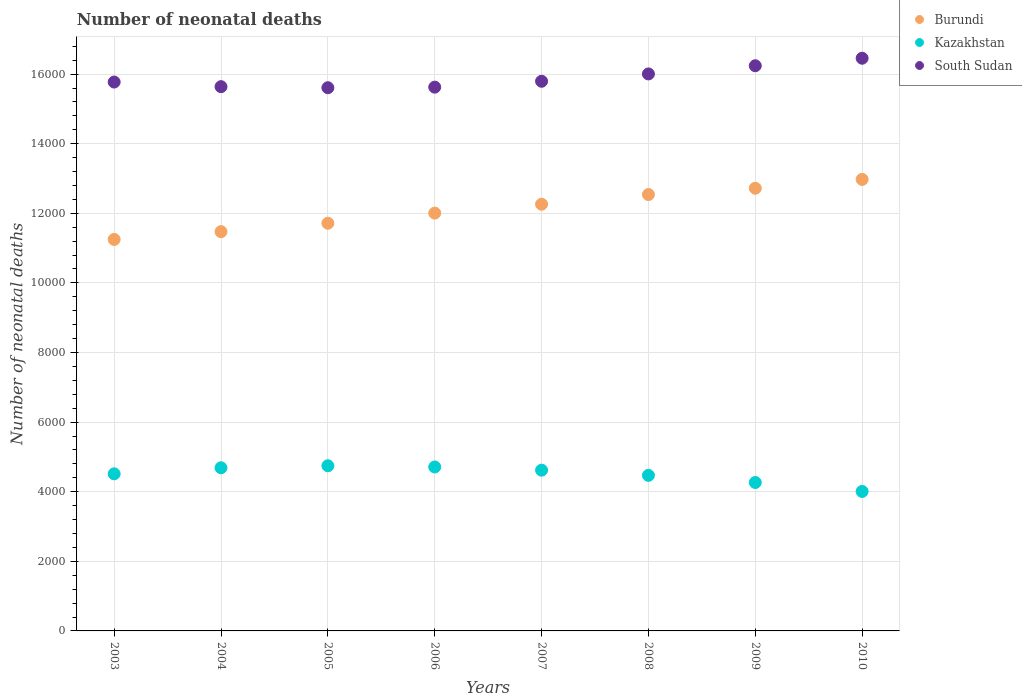How many different coloured dotlines are there?
Offer a terse response. 3. Is the number of dotlines equal to the number of legend labels?
Your answer should be very brief. Yes. What is the number of neonatal deaths in in Burundi in 2004?
Offer a terse response. 1.15e+04. Across all years, what is the maximum number of neonatal deaths in in Burundi?
Give a very brief answer. 1.30e+04. Across all years, what is the minimum number of neonatal deaths in in South Sudan?
Provide a short and direct response. 1.56e+04. What is the total number of neonatal deaths in in South Sudan in the graph?
Ensure brevity in your answer.  1.27e+05. What is the difference between the number of neonatal deaths in in Kazakhstan in 2008 and that in 2009?
Ensure brevity in your answer.  205. What is the difference between the number of neonatal deaths in in South Sudan in 2003 and the number of neonatal deaths in in Kazakhstan in 2009?
Your response must be concise. 1.15e+04. What is the average number of neonatal deaths in in South Sudan per year?
Offer a very short reply. 1.59e+04. In the year 2005, what is the difference between the number of neonatal deaths in in Burundi and number of neonatal deaths in in Kazakhstan?
Offer a very short reply. 6969. What is the ratio of the number of neonatal deaths in in Burundi in 2005 to that in 2009?
Ensure brevity in your answer.  0.92. Is the difference between the number of neonatal deaths in in Burundi in 2004 and 2005 greater than the difference between the number of neonatal deaths in in Kazakhstan in 2004 and 2005?
Your answer should be very brief. No. What is the difference between the highest and the second highest number of neonatal deaths in in Kazakhstan?
Ensure brevity in your answer.  35. What is the difference between the highest and the lowest number of neonatal deaths in in Kazakhstan?
Offer a very short reply. 738. Is it the case that in every year, the sum of the number of neonatal deaths in in Kazakhstan and number of neonatal deaths in in South Sudan  is greater than the number of neonatal deaths in in Burundi?
Offer a very short reply. Yes. Does the number of neonatal deaths in in Kazakhstan monotonically increase over the years?
Provide a short and direct response. No. Is the number of neonatal deaths in in South Sudan strictly less than the number of neonatal deaths in in Kazakhstan over the years?
Offer a very short reply. No. How many years are there in the graph?
Your response must be concise. 8. What is the difference between two consecutive major ticks on the Y-axis?
Provide a succinct answer. 2000. Are the values on the major ticks of Y-axis written in scientific E-notation?
Your response must be concise. No. How many legend labels are there?
Provide a succinct answer. 3. What is the title of the graph?
Provide a short and direct response. Number of neonatal deaths. What is the label or title of the Y-axis?
Give a very brief answer. Number of neonatal deaths. What is the Number of neonatal deaths of Burundi in 2003?
Offer a terse response. 1.12e+04. What is the Number of neonatal deaths of Kazakhstan in 2003?
Give a very brief answer. 4514. What is the Number of neonatal deaths of South Sudan in 2003?
Your answer should be very brief. 1.58e+04. What is the Number of neonatal deaths in Burundi in 2004?
Offer a very short reply. 1.15e+04. What is the Number of neonatal deaths of Kazakhstan in 2004?
Your answer should be compact. 4688. What is the Number of neonatal deaths in South Sudan in 2004?
Your answer should be compact. 1.56e+04. What is the Number of neonatal deaths of Burundi in 2005?
Provide a succinct answer. 1.17e+04. What is the Number of neonatal deaths in Kazakhstan in 2005?
Ensure brevity in your answer.  4746. What is the Number of neonatal deaths of South Sudan in 2005?
Your answer should be very brief. 1.56e+04. What is the Number of neonatal deaths in Burundi in 2006?
Your response must be concise. 1.20e+04. What is the Number of neonatal deaths in Kazakhstan in 2006?
Offer a very short reply. 4711. What is the Number of neonatal deaths in South Sudan in 2006?
Keep it short and to the point. 1.56e+04. What is the Number of neonatal deaths in Burundi in 2007?
Offer a terse response. 1.23e+04. What is the Number of neonatal deaths in Kazakhstan in 2007?
Your response must be concise. 4619. What is the Number of neonatal deaths of South Sudan in 2007?
Your response must be concise. 1.58e+04. What is the Number of neonatal deaths of Burundi in 2008?
Keep it short and to the point. 1.25e+04. What is the Number of neonatal deaths of Kazakhstan in 2008?
Give a very brief answer. 4470. What is the Number of neonatal deaths of South Sudan in 2008?
Ensure brevity in your answer.  1.60e+04. What is the Number of neonatal deaths in Burundi in 2009?
Your response must be concise. 1.27e+04. What is the Number of neonatal deaths in Kazakhstan in 2009?
Provide a short and direct response. 4265. What is the Number of neonatal deaths in South Sudan in 2009?
Your answer should be very brief. 1.62e+04. What is the Number of neonatal deaths of Burundi in 2010?
Your answer should be very brief. 1.30e+04. What is the Number of neonatal deaths of Kazakhstan in 2010?
Your answer should be very brief. 4008. What is the Number of neonatal deaths in South Sudan in 2010?
Your response must be concise. 1.65e+04. Across all years, what is the maximum Number of neonatal deaths of Burundi?
Your answer should be very brief. 1.30e+04. Across all years, what is the maximum Number of neonatal deaths of Kazakhstan?
Offer a very short reply. 4746. Across all years, what is the maximum Number of neonatal deaths in South Sudan?
Keep it short and to the point. 1.65e+04. Across all years, what is the minimum Number of neonatal deaths of Burundi?
Ensure brevity in your answer.  1.12e+04. Across all years, what is the minimum Number of neonatal deaths of Kazakhstan?
Offer a very short reply. 4008. Across all years, what is the minimum Number of neonatal deaths in South Sudan?
Offer a terse response. 1.56e+04. What is the total Number of neonatal deaths of Burundi in the graph?
Offer a very short reply. 9.69e+04. What is the total Number of neonatal deaths of Kazakhstan in the graph?
Your answer should be very brief. 3.60e+04. What is the total Number of neonatal deaths of South Sudan in the graph?
Ensure brevity in your answer.  1.27e+05. What is the difference between the Number of neonatal deaths in Burundi in 2003 and that in 2004?
Keep it short and to the point. -224. What is the difference between the Number of neonatal deaths in Kazakhstan in 2003 and that in 2004?
Make the answer very short. -174. What is the difference between the Number of neonatal deaths in South Sudan in 2003 and that in 2004?
Your answer should be very brief. 133. What is the difference between the Number of neonatal deaths of Burundi in 2003 and that in 2005?
Keep it short and to the point. -466. What is the difference between the Number of neonatal deaths of Kazakhstan in 2003 and that in 2005?
Make the answer very short. -232. What is the difference between the Number of neonatal deaths of South Sudan in 2003 and that in 2005?
Provide a short and direct response. 163. What is the difference between the Number of neonatal deaths in Burundi in 2003 and that in 2006?
Provide a short and direct response. -757. What is the difference between the Number of neonatal deaths in Kazakhstan in 2003 and that in 2006?
Give a very brief answer. -197. What is the difference between the Number of neonatal deaths of South Sudan in 2003 and that in 2006?
Offer a very short reply. 147. What is the difference between the Number of neonatal deaths of Burundi in 2003 and that in 2007?
Provide a short and direct response. -1012. What is the difference between the Number of neonatal deaths of Kazakhstan in 2003 and that in 2007?
Provide a short and direct response. -105. What is the difference between the Number of neonatal deaths in South Sudan in 2003 and that in 2007?
Your answer should be compact. -22. What is the difference between the Number of neonatal deaths in Burundi in 2003 and that in 2008?
Ensure brevity in your answer.  -1290. What is the difference between the Number of neonatal deaths in South Sudan in 2003 and that in 2008?
Your answer should be very brief. -233. What is the difference between the Number of neonatal deaths in Burundi in 2003 and that in 2009?
Ensure brevity in your answer.  -1471. What is the difference between the Number of neonatal deaths of Kazakhstan in 2003 and that in 2009?
Offer a very short reply. 249. What is the difference between the Number of neonatal deaths of South Sudan in 2003 and that in 2009?
Make the answer very short. -468. What is the difference between the Number of neonatal deaths in Burundi in 2003 and that in 2010?
Your answer should be compact. -1725. What is the difference between the Number of neonatal deaths of Kazakhstan in 2003 and that in 2010?
Keep it short and to the point. 506. What is the difference between the Number of neonatal deaths of South Sudan in 2003 and that in 2010?
Offer a terse response. -684. What is the difference between the Number of neonatal deaths of Burundi in 2004 and that in 2005?
Your answer should be compact. -242. What is the difference between the Number of neonatal deaths of Kazakhstan in 2004 and that in 2005?
Give a very brief answer. -58. What is the difference between the Number of neonatal deaths of South Sudan in 2004 and that in 2005?
Keep it short and to the point. 30. What is the difference between the Number of neonatal deaths in Burundi in 2004 and that in 2006?
Provide a succinct answer. -533. What is the difference between the Number of neonatal deaths in Burundi in 2004 and that in 2007?
Your answer should be compact. -788. What is the difference between the Number of neonatal deaths in South Sudan in 2004 and that in 2007?
Provide a succinct answer. -155. What is the difference between the Number of neonatal deaths in Burundi in 2004 and that in 2008?
Your answer should be compact. -1066. What is the difference between the Number of neonatal deaths in Kazakhstan in 2004 and that in 2008?
Your answer should be very brief. 218. What is the difference between the Number of neonatal deaths of South Sudan in 2004 and that in 2008?
Your answer should be very brief. -366. What is the difference between the Number of neonatal deaths in Burundi in 2004 and that in 2009?
Offer a very short reply. -1247. What is the difference between the Number of neonatal deaths in Kazakhstan in 2004 and that in 2009?
Make the answer very short. 423. What is the difference between the Number of neonatal deaths of South Sudan in 2004 and that in 2009?
Ensure brevity in your answer.  -601. What is the difference between the Number of neonatal deaths of Burundi in 2004 and that in 2010?
Your answer should be compact. -1501. What is the difference between the Number of neonatal deaths in Kazakhstan in 2004 and that in 2010?
Make the answer very short. 680. What is the difference between the Number of neonatal deaths of South Sudan in 2004 and that in 2010?
Offer a terse response. -817. What is the difference between the Number of neonatal deaths of Burundi in 2005 and that in 2006?
Your answer should be very brief. -291. What is the difference between the Number of neonatal deaths in Kazakhstan in 2005 and that in 2006?
Make the answer very short. 35. What is the difference between the Number of neonatal deaths in Burundi in 2005 and that in 2007?
Your answer should be very brief. -546. What is the difference between the Number of neonatal deaths in Kazakhstan in 2005 and that in 2007?
Your answer should be compact. 127. What is the difference between the Number of neonatal deaths of South Sudan in 2005 and that in 2007?
Your response must be concise. -185. What is the difference between the Number of neonatal deaths in Burundi in 2005 and that in 2008?
Ensure brevity in your answer.  -824. What is the difference between the Number of neonatal deaths of Kazakhstan in 2005 and that in 2008?
Your response must be concise. 276. What is the difference between the Number of neonatal deaths of South Sudan in 2005 and that in 2008?
Provide a short and direct response. -396. What is the difference between the Number of neonatal deaths of Burundi in 2005 and that in 2009?
Keep it short and to the point. -1005. What is the difference between the Number of neonatal deaths in Kazakhstan in 2005 and that in 2009?
Keep it short and to the point. 481. What is the difference between the Number of neonatal deaths of South Sudan in 2005 and that in 2009?
Make the answer very short. -631. What is the difference between the Number of neonatal deaths in Burundi in 2005 and that in 2010?
Make the answer very short. -1259. What is the difference between the Number of neonatal deaths in Kazakhstan in 2005 and that in 2010?
Your answer should be compact. 738. What is the difference between the Number of neonatal deaths of South Sudan in 2005 and that in 2010?
Your answer should be compact. -847. What is the difference between the Number of neonatal deaths in Burundi in 2006 and that in 2007?
Your answer should be compact. -255. What is the difference between the Number of neonatal deaths in Kazakhstan in 2006 and that in 2007?
Your answer should be very brief. 92. What is the difference between the Number of neonatal deaths in South Sudan in 2006 and that in 2007?
Your answer should be compact. -169. What is the difference between the Number of neonatal deaths of Burundi in 2006 and that in 2008?
Offer a very short reply. -533. What is the difference between the Number of neonatal deaths of Kazakhstan in 2006 and that in 2008?
Offer a very short reply. 241. What is the difference between the Number of neonatal deaths in South Sudan in 2006 and that in 2008?
Provide a short and direct response. -380. What is the difference between the Number of neonatal deaths of Burundi in 2006 and that in 2009?
Provide a succinct answer. -714. What is the difference between the Number of neonatal deaths in Kazakhstan in 2006 and that in 2009?
Give a very brief answer. 446. What is the difference between the Number of neonatal deaths in South Sudan in 2006 and that in 2009?
Give a very brief answer. -615. What is the difference between the Number of neonatal deaths in Burundi in 2006 and that in 2010?
Your answer should be compact. -968. What is the difference between the Number of neonatal deaths of Kazakhstan in 2006 and that in 2010?
Offer a terse response. 703. What is the difference between the Number of neonatal deaths of South Sudan in 2006 and that in 2010?
Offer a terse response. -831. What is the difference between the Number of neonatal deaths in Burundi in 2007 and that in 2008?
Offer a terse response. -278. What is the difference between the Number of neonatal deaths of Kazakhstan in 2007 and that in 2008?
Keep it short and to the point. 149. What is the difference between the Number of neonatal deaths in South Sudan in 2007 and that in 2008?
Give a very brief answer. -211. What is the difference between the Number of neonatal deaths of Burundi in 2007 and that in 2009?
Provide a succinct answer. -459. What is the difference between the Number of neonatal deaths in Kazakhstan in 2007 and that in 2009?
Your response must be concise. 354. What is the difference between the Number of neonatal deaths of South Sudan in 2007 and that in 2009?
Offer a terse response. -446. What is the difference between the Number of neonatal deaths of Burundi in 2007 and that in 2010?
Provide a short and direct response. -713. What is the difference between the Number of neonatal deaths in Kazakhstan in 2007 and that in 2010?
Ensure brevity in your answer.  611. What is the difference between the Number of neonatal deaths in South Sudan in 2007 and that in 2010?
Keep it short and to the point. -662. What is the difference between the Number of neonatal deaths of Burundi in 2008 and that in 2009?
Offer a very short reply. -181. What is the difference between the Number of neonatal deaths in Kazakhstan in 2008 and that in 2009?
Your answer should be very brief. 205. What is the difference between the Number of neonatal deaths of South Sudan in 2008 and that in 2009?
Offer a very short reply. -235. What is the difference between the Number of neonatal deaths in Burundi in 2008 and that in 2010?
Your response must be concise. -435. What is the difference between the Number of neonatal deaths of Kazakhstan in 2008 and that in 2010?
Provide a short and direct response. 462. What is the difference between the Number of neonatal deaths of South Sudan in 2008 and that in 2010?
Offer a very short reply. -451. What is the difference between the Number of neonatal deaths of Burundi in 2009 and that in 2010?
Ensure brevity in your answer.  -254. What is the difference between the Number of neonatal deaths in Kazakhstan in 2009 and that in 2010?
Your answer should be compact. 257. What is the difference between the Number of neonatal deaths in South Sudan in 2009 and that in 2010?
Keep it short and to the point. -216. What is the difference between the Number of neonatal deaths of Burundi in 2003 and the Number of neonatal deaths of Kazakhstan in 2004?
Your response must be concise. 6561. What is the difference between the Number of neonatal deaths in Burundi in 2003 and the Number of neonatal deaths in South Sudan in 2004?
Offer a terse response. -4390. What is the difference between the Number of neonatal deaths in Kazakhstan in 2003 and the Number of neonatal deaths in South Sudan in 2004?
Ensure brevity in your answer.  -1.11e+04. What is the difference between the Number of neonatal deaths in Burundi in 2003 and the Number of neonatal deaths in Kazakhstan in 2005?
Provide a succinct answer. 6503. What is the difference between the Number of neonatal deaths in Burundi in 2003 and the Number of neonatal deaths in South Sudan in 2005?
Keep it short and to the point. -4360. What is the difference between the Number of neonatal deaths in Kazakhstan in 2003 and the Number of neonatal deaths in South Sudan in 2005?
Give a very brief answer. -1.11e+04. What is the difference between the Number of neonatal deaths in Burundi in 2003 and the Number of neonatal deaths in Kazakhstan in 2006?
Your answer should be very brief. 6538. What is the difference between the Number of neonatal deaths of Burundi in 2003 and the Number of neonatal deaths of South Sudan in 2006?
Your answer should be compact. -4376. What is the difference between the Number of neonatal deaths in Kazakhstan in 2003 and the Number of neonatal deaths in South Sudan in 2006?
Offer a terse response. -1.11e+04. What is the difference between the Number of neonatal deaths of Burundi in 2003 and the Number of neonatal deaths of Kazakhstan in 2007?
Offer a very short reply. 6630. What is the difference between the Number of neonatal deaths in Burundi in 2003 and the Number of neonatal deaths in South Sudan in 2007?
Keep it short and to the point. -4545. What is the difference between the Number of neonatal deaths in Kazakhstan in 2003 and the Number of neonatal deaths in South Sudan in 2007?
Your answer should be compact. -1.13e+04. What is the difference between the Number of neonatal deaths in Burundi in 2003 and the Number of neonatal deaths in Kazakhstan in 2008?
Provide a short and direct response. 6779. What is the difference between the Number of neonatal deaths in Burundi in 2003 and the Number of neonatal deaths in South Sudan in 2008?
Offer a very short reply. -4756. What is the difference between the Number of neonatal deaths in Kazakhstan in 2003 and the Number of neonatal deaths in South Sudan in 2008?
Give a very brief answer. -1.15e+04. What is the difference between the Number of neonatal deaths of Burundi in 2003 and the Number of neonatal deaths of Kazakhstan in 2009?
Your response must be concise. 6984. What is the difference between the Number of neonatal deaths in Burundi in 2003 and the Number of neonatal deaths in South Sudan in 2009?
Ensure brevity in your answer.  -4991. What is the difference between the Number of neonatal deaths in Kazakhstan in 2003 and the Number of neonatal deaths in South Sudan in 2009?
Your response must be concise. -1.17e+04. What is the difference between the Number of neonatal deaths of Burundi in 2003 and the Number of neonatal deaths of Kazakhstan in 2010?
Ensure brevity in your answer.  7241. What is the difference between the Number of neonatal deaths in Burundi in 2003 and the Number of neonatal deaths in South Sudan in 2010?
Ensure brevity in your answer.  -5207. What is the difference between the Number of neonatal deaths of Kazakhstan in 2003 and the Number of neonatal deaths of South Sudan in 2010?
Make the answer very short. -1.19e+04. What is the difference between the Number of neonatal deaths of Burundi in 2004 and the Number of neonatal deaths of Kazakhstan in 2005?
Your response must be concise. 6727. What is the difference between the Number of neonatal deaths in Burundi in 2004 and the Number of neonatal deaths in South Sudan in 2005?
Provide a short and direct response. -4136. What is the difference between the Number of neonatal deaths in Kazakhstan in 2004 and the Number of neonatal deaths in South Sudan in 2005?
Offer a terse response. -1.09e+04. What is the difference between the Number of neonatal deaths in Burundi in 2004 and the Number of neonatal deaths in Kazakhstan in 2006?
Ensure brevity in your answer.  6762. What is the difference between the Number of neonatal deaths of Burundi in 2004 and the Number of neonatal deaths of South Sudan in 2006?
Make the answer very short. -4152. What is the difference between the Number of neonatal deaths in Kazakhstan in 2004 and the Number of neonatal deaths in South Sudan in 2006?
Make the answer very short. -1.09e+04. What is the difference between the Number of neonatal deaths in Burundi in 2004 and the Number of neonatal deaths in Kazakhstan in 2007?
Provide a succinct answer. 6854. What is the difference between the Number of neonatal deaths of Burundi in 2004 and the Number of neonatal deaths of South Sudan in 2007?
Ensure brevity in your answer.  -4321. What is the difference between the Number of neonatal deaths in Kazakhstan in 2004 and the Number of neonatal deaths in South Sudan in 2007?
Provide a succinct answer. -1.11e+04. What is the difference between the Number of neonatal deaths of Burundi in 2004 and the Number of neonatal deaths of Kazakhstan in 2008?
Provide a succinct answer. 7003. What is the difference between the Number of neonatal deaths of Burundi in 2004 and the Number of neonatal deaths of South Sudan in 2008?
Offer a very short reply. -4532. What is the difference between the Number of neonatal deaths of Kazakhstan in 2004 and the Number of neonatal deaths of South Sudan in 2008?
Provide a succinct answer. -1.13e+04. What is the difference between the Number of neonatal deaths of Burundi in 2004 and the Number of neonatal deaths of Kazakhstan in 2009?
Provide a succinct answer. 7208. What is the difference between the Number of neonatal deaths in Burundi in 2004 and the Number of neonatal deaths in South Sudan in 2009?
Your answer should be compact. -4767. What is the difference between the Number of neonatal deaths of Kazakhstan in 2004 and the Number of neonatal deaths of South Sudan in 2009?
Your answer should be compact. -1.16e+04. What is the difference between the Number of neonatal deaths of Burundi in 2004 and the Number of neonatal deaths of Kazakhstan in 2010?
Your answer should be compact. 7465. What is the difference between the Number of neonatal deaths of Burundi in 2004 and the Number of neonatal deaths of South Sudan in 2010?
Provide a succinct answer. -4983. What is the difference between the Number of neonatal deaths of Kazakhstan in 2004 and the Number of neonatal deaths of South Sudan in 2010?
Provide a succinct answer. -1.18e+04. What is the difference between the Number of neonatal deaths in Burundi in 2005 and the Number of neonatal deaths in Kazakhstan in 2006?
Your answer should be very brief. 7004. What is the difference between the Number of neonatal deaths of Burundi in 2005 and the Number of neonatal deaths of South Sudan in 2006?
Make the answer very short. -3910. What is the difference between the Number of neonatal deaths of Kazakhstan in 2005 and the Number of neonatal deaths of South Sudan in 2006?
Give a very brief answer. -1.09e+04. What is the difference between the Number of neonatal deaths of Burundi in 2005 and the Number of neonatal deaths of Kazakhstan in 2007?
Ensure brevity in your answer.  7096. What is the difference between the Number of neonatal deaths of Burundi in 2005 and the Number of neonatal deaths of South Sudan in 2007?
Provide a short and direct response. -4079. What is the difference between the Number of neonatal deaths of Kazakhstan in 2005 and the Number of neonatal deaths of South Sudan in 2007?
Your answer should be very brief. -1.10e+04. What is the difference between the Number of neonatal deaths of Burundi in 2005 and the Number of neonatal deaths of Kazakhstan in 2008?
Make the answer very short. 7245. What is the difference between the Number of neonatal deaths of Burundi in 2005 and the Number of neonatal deaths of South Sudan in 2008?
Keep it short and to the point. -4290. What is the difference between the Number of neonatal deaths of Kazakhstan in 2005 and the Number of neonatal deaths of South Sudan in 2008?
Keep it short and to the point. -1.13e+04. What is the difference between the Number of neonatal deaths of Burundi in 2005 and the Number of neonatal deaths of Kazakhstan in 2009?
Your answer should be compact. 7450. What is the difference between the Number of neonatal deaths of Burundi in 2005 and the Number of neonatal deaths of South Sudan in 2009?
Offer a terse response. -4525. What is the difference between the Number of neonatal deaths in Kazakhstan in 2005 and the Number of neonatal deaths in South Sudan in 2009?
Give a very brief answer. -1.15e+04. What is the difference between the Number of neonatal deaths of Burundi in 2005 and the Number of neonatal deaths of Kazakhstan in 2010?
Your response must be concise. 7707. What is the difference between the Number of neonatal deaths of Burundi in 2005 and the Number of neonatal deaths of South Sudan in 2010?
Keep it short and to the point. -4741. What is the difference between the Number of neonatal deaths of Kazakhstan in 2005 and the Number of neonatal deaths of South Sudan in 2010?
Make the answer very short. -1.17e+04. What is the difference between the Number of neonatal deaths in Burundi in 2006 and the Number of neonatal deaths in Kazakhstan in 2007?
Give a very brief answer. 7387. What is the difference between the Number of neonatal deaths of Burundi in 2006 and the Number of neonatal deaths of South Sudan in 2007?
Offer a terse response. -3788. What is the difference between the Number of neonatal deaths in Kazakhstan in 2006 and the Number of neonatal deaths in South Sudan in 2007?
Offer a very short reply. -1.11e+04. What is the difference between the Number of neonatal deaths of Burundi in 2006 and the Number of neonatal deaths of Kazakhstan in 2008?
Your answer should be compact. 7536. What is the difference between the Number of neonatal deaths in Burundi in 2006 and the Number of neonatal deaths in South Sudan in 2008?
Make the answer very short. -3999. What is the difference between the Number of neonatal deaths of Kazakhstan in 2006 and the Number of neonatal deaths of South Sudan in 2008?
Ensure brevity in your answer.  -1.13e+04. What is the difference between the Number of neonatal deaths in Burundi in 2006 and the Number of neonatal deaths in Kazakhstan in 2009?
Provide a short and direct response. 7741. What is the difference between the Number of neonatal deaths in Burundi in 2006 and the Number of neonatal deaths in South Sudan in 2009?
Keep it short and to the point. -4234. What is the difference between the Number of neonatal deaths in Kazakhstan in 2006 and the Number of neonatal deaths in South Sudan in 2009?
Provide a short and direct response. -1.15e+04. What is the difference between the Number of neonatal deaths of Burundi in 2006 and the Number of neonatal deaths of Kazakhstan in 2010?
Offer a very short reply. 7998. What is the difference between the Number of neonatal deaths of Burundi in 2006 and the Number of neonatal deaths of South Sudan in 2010?
Ensure brevity in your answer.  -4450. What is the difference between the Number of neonatal deaths of Kazakhstan in 2006 and the Number of neonatal deaths of South Sudan in 2010?
Keep it short and to the point. -1.17e+04. What is the difference between the Number of neonatal deaths in Burundi in 2007 and the Number of neonatal deaths in Kazakhstan in 2008?
Provide a succinct answer. 7791. What is the difference between the Number of neonatal deaths of Burundi in 2007 and the Number of neonatal deaths of South Sudan in 2008?
Ensure brevity in your answer.  -3744. What is the difference between the Number of neonatal deaths in Kazakhstan in 2007 and the Number of neonatal deaths in South Sudan in 2008?
Ensure brevity in your answer.  -1.14e+04. What is the difference between the Number of neonatal deaths of Burundi in 2007 and the Number of neonatal deaths of Kazakhstan in 2009?
Your response must be concise. 7996. What is the difference between the Number of neonatal deaths in Burundi in 2007 and the Number of neonatal deaths in South Sudan in 2009?
Provide a short and direct response. -3979. What is the difference between the Number of neonatal deaths in Kazakhstan in 2007 and the Number of neonatal deaths in South Sudan in 2009?
Ensure brevity in your answer.  -1.16e+04. What is the difference between the Number of neonatal deaths of Burundi in 2007 and the Number of neonatal deaths of Kazakhstan in 2010?
Offer a terse response. 8253. What is the difference between the Number of neonatal deaths in Burundi in 2007 and the Number of neonatal deaths in South Sudan in 2010?
Your response must be concise. -4195. What is the difference between the Number of neonatal deaths in Kazakhstan in 2007 and the Number of neonatal deaths in South Sudan in 2010?
Your answer should be very brief. -1.18e+04. What is the difference between the Number of neonatal deaths in Burundi in 2008 and the Number of neonatal deaths in Kazakhstan in 2009?
Make the answer very short. 8274. What is the difference between the Number of neonatal deaths in Burundi in 2008 and the Number of neonatal deaths in South Sudan in 2009?
Your answer should be compact. -3701. What is the difference between the Number of neonatal deaths of Kazakhstan in 2008 and the Number of neonatal deaths of South Sudan in 2009?
Your response must be concise. -1.18e+04. What is the difference between the Number of neonatal deaths in Burundi in 2008 and the Number of neonatal deaths in Kazakhstan in 2010?
Provide a short and direct response. 8531. What is the difference between the Number of neonatal deaths of Burundi in 2008 and the Number of neonatal deaths of South Sudan in 2010?
Ensure brevity in your answer.  -3917. What is the difference between the Number of neonatal deaths in Kazakhstan in 2008 and the Number of neonatal deaths in South Sudan in 2010?
Ensure brevity in your answer.  -1.20e+04. What is the difference between the Number of neonatal deaths of Burundi in 2009 and the Number of neonatal deaths of Kazakhstan in 2010?
Offer a terse response. 8712. What is the difference between the Number of neonatal deaths of Burundi in 2009 and the Number of neonatal deaths of South Sudan in 2010?
Offer a very short reply. -3736. What is the difference between the Number of neonatal deaths in Kazakhstan in 2009 and the Number of neonatal deaths in South Sudan in 2010?
Give a very brief answer. -1.22e+04. What is the average Number of neonatal deaths of Burundi per year?
Your response must be concise. 1.21e+04. What is the average Number of neonatal deaths in Kazakhstan per year?
Offer a very short reply. 4502.62. What is the average Number of neonatal deaths in South Sudan per year?
Keep it short and to the point. 1.59e+04. In the year 2003, what is the difference between the Number of neonatal deaths in Burundi and Number of neonatal deaths in Kazakhstan?
Provide a succinct answer. 6735. In the year 2003, what is the difference between the Number of neonatal deaths in Burundi and Number of neonatal deaths in South Sudan?
Provide a short and direct response. -4523. In the year 2003, what is the difference between the Number of neonatal deaths of Kazakhstan and Number of neonatal deaths of South Sudan?
Keep it short and to the point. -1.13e+04. In the year 2004, what is the difference between the Number of neonatal deaths of Burundi and Number of neonatal deaths of Kazakhstan?
Give a very brief answer. 6785. In the year 2004, what is the difference between the Number of neonatal deaths of Burundi and Number of neonatal deaths of South Sudan?
Make the answer very short. -4166. In the year 2004, what is the difference between the Number of neonatal deaths in Kazakhstan and Number of neonatal deaths in South Sudan?
Your answer should be very brief. -1.10e+04. In the year 2005, what is the difference between the Number of neonatal deaths of Burundi and Number of neonatal deaths of Kazakhstan?
Your answer should be compact. 6969. In the year 2005, what is the difference between the Number of neonatal deaths of Burundi and Number of neonatal deaths of South Sudan?
Offer a terse response. -3894. In the year 2005, what is the difference between the Number of neonatal deaths of Kazakhstan and Number of neonatal deaths of South Sudan?
Your answer should be compact. -1.09e+04. In the year 2006, what is the difference between the Number of neonatal deaths of Burundi and Number of neonatal deaths of Kazakhstan?
Offer a very short reply. 7295. In the year 2006, what is the difference between the Number of neonatal deaths in Burundi and Number of neonatal deaths in South Sudan?
Your answer should be compact. -3619. In the year 2006, what is the difference between the Number of neonatal deaths in Kazakhstan and Number of neonatal deaths in South Sudan?
Give a very brief answer. -1.09e+04. In the year 2007, what is the difference between the Number of neonatal deaths in Burundi and Number of neonatal deaths in Kazakhstan?
Make the answer very short. 7642. In the year 2007, what is the difference between the Number of neonatal deaths of Burundi and Number of neonatal deaths of South Sudan?
Give a very brief answer. -3533. In the year 2007, what is the difference between the Number of neonatal deaths in Kazakhstan and Number of neonatal deaths in South Sudan?
Make the answer very short. -1.12e+04. In the year 2008, what is the difference between the Number of neonatal deaths in Burundi and Number of neonatal deaths in Kazakhstan?
Offer a terse response. 8069. In the year 2008, what is the difference between the Number of neonatal deaths of Burundi and Number of neonatal deaths of South Sudan?
Offer a very short reply. -3466. In the year 2008, what is the difference between the Number of neonatal deaths in Kazakhstan and Number of neonatal deaths in South Sudan?
Your answer should be very brief. -1.15e+04. In the year 2009, what is the difference between the Number of neonatal deaths in Burundi and Number of neonatal deaths in Kazakhstan?
Make the answer very short. 8455. In the year 2009, what is the difference between the Number of neonatal deaths of Burundi and Number of neonatal deaths of South Sudan?
Ensure brevity in your answer.  -3520. In the year 2009, what is the difference between the Number of neonatal deaths in Kazakhstan and Number of neonatal deaths in South Sudan?
Your answer should be compact. -1.20e+04. In the year 2010, what is the difference between the Number of neonatal deaths of Burundi and Number of neonatal deaths of Kazakhstan?
Your response must be concise. 8966. In the year 2010, what is the difference between the Number of neonatal deaths in Burundi and Number of neonatal deaths in South Sudan?
Provide a succinct answer. -3482. In the year 2010, what is the difference between the Number of neonatal deaths of Kazakhstan and Number of neonatal deaths of South Sudan?
Your answer should be compact. -1.24e+04. What is the ratio of the Number of neonatal deaths in Burundi in 2003 to that in 2004?
Your answer should be compact. 0.98. What is the ratio of the Number of neonatal deaths of Kazakhstan in 2003 to that in 2004?
Offer a terse response. 0.96. What is the ratio of the Number of neonatal deaths in South Sudan in 2003 to that in 2004?
Your answer should be compact. 1.01. What is the ratio of the Number of neonatal deaths in Burundi in 2003 to that in 2005?
Make the answer very short. 0.96. What is the ratio of the Number of neonatal deaths in Kazakhstan in 2003 to that in 2005?
Provide a succinct answer. 0.95. What is the ratio of the Number of neonatal deaths of South Sudan in 2003 to that in 2005?
Provide a succinct answer. 1.01. What is the ratio of the Number of neonatal deaths in Burundi in 2003 to that in 2006?
Your answer should be compact. 0.94. What is the ratio of the Number of neonatal deaths of Kazakhstan in 2003 to that in 2006?
Keep it short and to the point. 0.96. What is the ratio of the Number of neonatal deaths of South Sudan in 2003 to that in 2006?
Ensure brevity in your answer.  1.01. What is the ratio of the Number of neonatal deaths in Burundi in 2003 to that in 2007?
Your response must be concise. 0.92. What is the ratio of the Number of neonatal deaths in Kazakhstan in 2003 to that in 2007?
Keep it short and to the point. 0.98. What is the ratio of the Number of neonatal deaths in Burundi in 2003 to that in 2008?
Offer a very short reply. 0.9. What is the ratio of the Number of neonatal deaths of Kazakhstan in 2003 to that in 2008?
Offer a very short reply. 1.01. What is the ratio of the Number of neonatal deaths in South Sudan in 2003 to that in 2008?
Give a very brief answer. 0.99. What is the ratio of the Number of neonatal deaths in Burundi in 2003 to that in 2009?
Provide a short and direct response. 0.88. What is the ratio of the Number of neonatal deaths of Kazakhstan in 2003 to that in 2009?
Ensure brevity in your answer.  1.06. What is the ratio of the Number of neonatal deaths of South Sudan in 2003 to that in 2009?
Give a very brief answer. 0.97. What is the ratio of the Number of neonatal deaths of Burundi in 2003 to that in 2010?
Your response must be concise. 0.87. What is the ratio of the Number of neonatal deaths in Kazakhstan in 2003 to that in 2010?
Ensure brevity in your answer.  1.13. What is the ratio of the Number of neonatal deaths in South Sudan in 2003 to that in 2010?
Provide a succinct answer. 0.96. What is the ratio of the Number of neonatal deaths in Burundi in 2004 to that in 2005?
Provide a succinct answer. 0.98. What is the ratio of the Number of neonatal deaths in Burundi in 2004 to that in 2006?
Your response must be concise. 0.96. What is the ratio of the Number of neonatal deaths of Kazakhstan in 2004 to that in 2006?
Your response must be concise. 1. What is the ratio of the Number of neonatal deaths in Burundi in 2004 to that in 2007?
Your answer should be compact. 0.94. What is the ratio of the Number of neonatal deaths in Kazakhstan in 2004 to that in 2007?
Offer a terse response. 1.01. What is the ratio of the Number of neonatal deaths of South Sudan in 2004 to that in 2007?
Make the answer very short. 0.99. What is the ratio of the Number of neonatal deaths in Burundi in 2004 to that in 2008?
Ensure brevity in your answer.  0.92. What is the ratio of the Number of neonatal deaths in Kazakhstan in 2004 to that in 2008?
Make the answer very short. 1.05. What is the ratio of the Number of neonatal deaths in South Sudan in 2004 to that in 2008?
Your answer should be very brief. 0.98. What is the ratio of the Number of neonatal deaths in Burundi in 2004 to that in 2009?
Keep it short and to the point. 0.9. What is the ratio of the Number of neonatal deaths in Kazakhstan in 2004 to that in 2009?
Offer a terse response. 1.1. What is the ratio of the Number of neonatal deaths in Burundi in 2004 to that in 2010?
Give a very brief answer. 0.88. What is the ratio of the Number of neonatal deaths of Kazakhstan in 2004 to that in 2010?
Keep it short and to the point. 1.17. What is the ratio of the Number of neonatal deaths of South Sudan in 2004 to that in 2010?
Your response must be concise. 0.95. What is the ratio of the Number of neonatal deaths in Burundi in 2005 to that in 2006?
Provide a succinct answer. 0.98. What is the ratio of the Number of neonatal deaths in Kazakhstan in 2005 to that in 2006?
Your response must be concise. 1.01. What is the ratio of the Number of neonatal deaths in South Sudan in 2005 to that in 2006?
Offer a very short reply. 1. What is the ratio of the Number of neonatal deaths of Burundi in 2005 to that in 2007?
Ensure brevity in your answer.  0.96. What is the ratio of the Number of neonatal deaths of Kazakhstan in 2005 to that in 2007?
Make the answer very short. 1.03. What is the ratio of the Number of neonatal deaths in South Sudan in 2005 to that in 2007?
Provide a succinct answer. 0.99. What is the ratio of the Number of neonatal deaths of Burundi in 2005 to that in 2008?
Give a very brief answer. 0.93. What is the ratio of the Number of neonatal deaths in Kazakhstan in 2005 to that in 2008?
Offer a terse response. 1.06. What is the ratio of the Number of neonatal deaths in South Sudan in 2005 to that in 2008?
Your response must be concise. 0.98. What is the ratio of the Number of neonatal deaths of Burundi in 2005 to that in 2009?
Give a very brief answer. 0.92. What is the ratio of the Number of neonatal deaths of Kazakhstan in 2005 to that in 2009?
Give a very brief answer. 1.11. What is the ratio of the Number of neonatal deaths in South Sudan in 2005 to that in 2009?
Ensure brevity in your answer.  0.96. What is the ratio of the Number of neonatal deaths of Burundi in 2005 to that in 2010?
Your answer should be very brief. 0.9. What is the ratio of the Number of neonatal deaths of Kazakhstan in 2005 to that in 2010?
Give a very brief answer. 1.18. What is the ratio of the Number of neonatal deaths of South Sudan in 2005 to that in 2010?
Provide a succinct answer. 0.95. What is the ratio of the Number of neonatal deaths in Burundi in 2006 to that in 2007?
Make the answer very short. 0.98. What is the ratio of the Number of neonatal deaths in Kazakhstan in 2006 to that in 2007?
Provide a short and direct response. 1.02. What is the ratio of the Number of neonatal deaths in South Sudan in 2006 to that in 2007?
Ensure brevity in your answer.  0.99. What is the ratio of the Number of neonatal deaths in Burundi in 2006 to that in 2008?
Provide a short and direct response. 0.96. What is the ratio of the Number of neonatal deaths of Kazakhstan in 2006 to that in 2008?
Your answer should be very brief. 1.05. What is the ratio of the Number of neonatal deaths in South Sudan in 2006 to that in 2008?
Your response must be concise. 0.98. What is the ratio of the Number of neonatal deaths of Burundi in 2006 to that in 2009?
Your answer should be very brief. 0.94. What is the ratio of the Number of neonatal deaths in Kazakhstan in 2006 to that in 2009?
Provide a succinct answer. 1.1. What is the ratio of the Number of neonatal deaths in South Sudan in 2006 to that in 2009?
Offer a very short reply. 0.96. What is the ratio of the Number of neonatal deaths of Burundi in 2006 to that in 2010?
Make the answer very short. 0.93. What is the ratio of the Number of neonatal deaths of Kazakhstan in 2006 to that in 2010?
Give a very brief answer. 1.18. What is the ratio of the Number of neonatal deaths of South Sudan in 2006 to that in 2010?
Keep it short and to the point. 0.95. What is the ratio of the Number of neonatal deaths of Burundi in 2007 to that in 2008?
Offer a terse response. 0.98. What is the ratio of the Number of neonatal deaths of Burundi in 2007 to that in 2009?
Offer a very short reply. 0.96. What is the ratio of the Number of neonatal deaths in Kazakhstan in 2007 to that in 2009?
Offer a terse response. 1.08. What is the ratio of the Number of neonatal deaths in South Sudan in 2007 to that in 2009?
Your answer should be compact. 0.97. What is the ratio of the Number of neonatal deaths of Burundi in 2007 to that in 2010?
Your response must be concise. 0.94. What is the ratio of the Number of neonatal deaths in Kazakhstan in 2007 to that in 2010?
Your response must be concise. 1.15. What is the ratio of the Number of neonatal deaths in South Sudan in 2007 to that in 2010?
Offer a terse response. 0.96. What is the ratio of the Number of neonatal deaths of Burundi in 2008 to that in 2009?
Provide a short and direct response. 0.99. What is the ratio of the Number of neonatal deaths in Kazakhstan in 2008 to that in 2009?
Offer a very short reply. 1.05. What is the ratio of the Number of neonatal deaths in South Sudan in 2008 to that in 2009?
Offer a terse response. 0.99. What is the ratio of the Number of neonatal deaths of Burundi in 2008 to that in 2010?
Offer a terse response. 0.97. What is the ratio of the Number of neonatal deaths of Kazakhstan in 2008 to that in 2010?
Offer a very short reply. 1.12. What is the ratio of the Number of neonatal deaths in South Sudan in 2008 to that in 2010?
Ensure brevity in your answer.  0.97. What is the ratio of the Number of neonatal deaths of Burundi in 2009 to that in 2010?
Make the answer very short. 0.98. What is the ratio of the Number of neonatal deaths in Kazakhstan in 2009 to that in 2010?
Keep it short and to the point. 1.06. What is the ratio of the Number of neonatal deaths in South Sudan in 2009 to that in 2010?
Your answer should be very brief. 0.99. What is the difference between the highest and the second highest Number of neonatal deaths in Burundi?
Keep it short and to the point. 254. What is the difference between the highest and the second highest Number of neonatal deaths of South Sudan?
Offer a very short reply. 216. What is the difference between the highest and the lowest Number of neonatal deaths of Burundi?
Provide a short and direct response. 1725. What is the difference between the highest and the lowest Number of neonatal deaths in Kazakhstan?
Your response must be concise. 738. What is the difference between the highest and the lowest Number of neonatal deaths of South Sudan?
Provide a short and direct response. 847. 